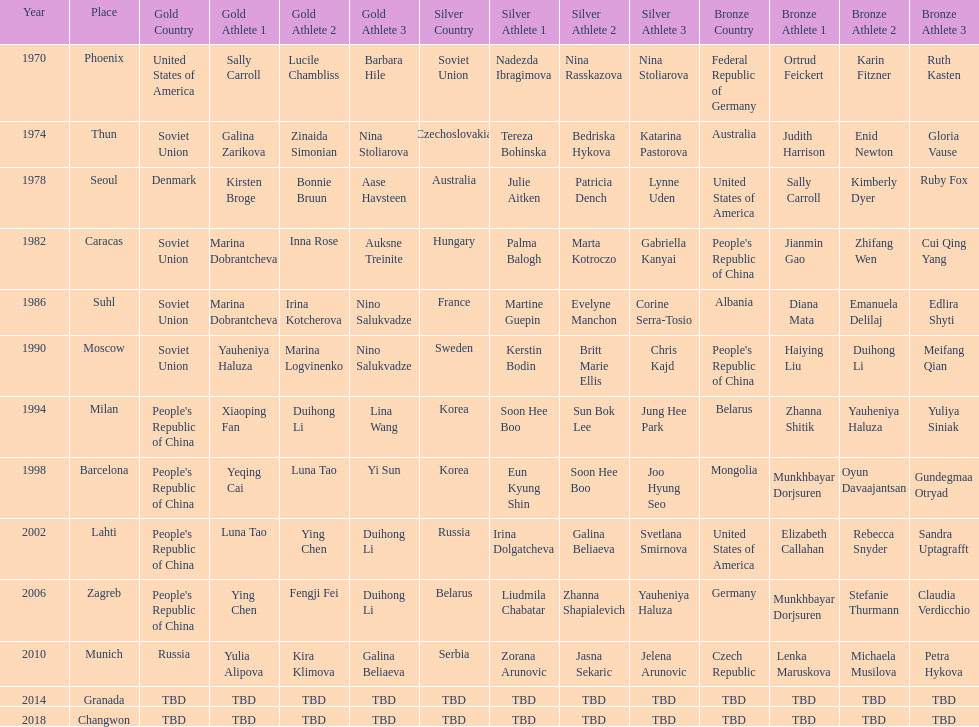How many world championships had the soviet union won first place in in the 25 metre pistol women's world championship? 4. 